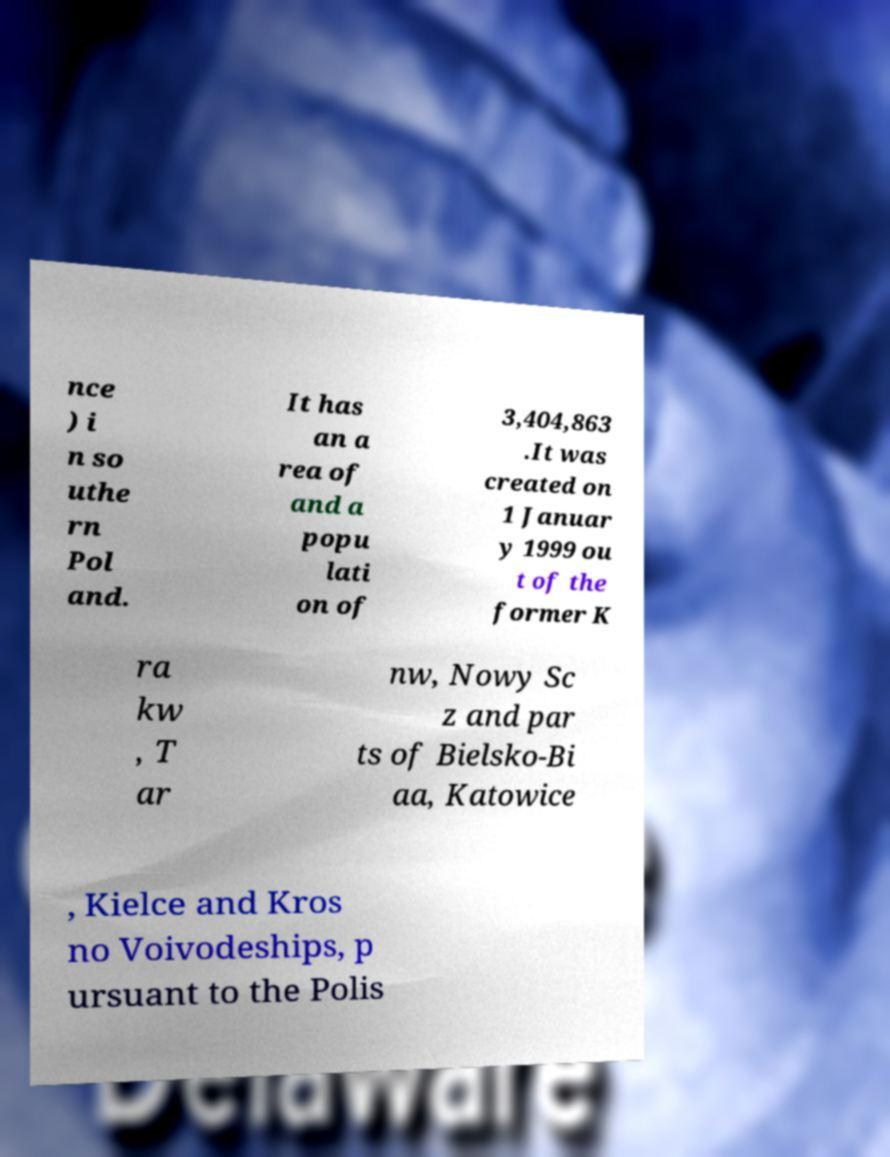Can you accurately transcribe the text from the provided image for me? nce ) i n so uthe rn Pol and. It has an a rea of and a popu lati on of 3,404,863 .It was created on 1 Januar y 1999 ou t of the former K ra kw , T ar nw, Nowy Sc z and par ts of Bielsko-Bi aa, Katowice , Kielce and Kros no Voivodeships, p ursuant to the Polis 